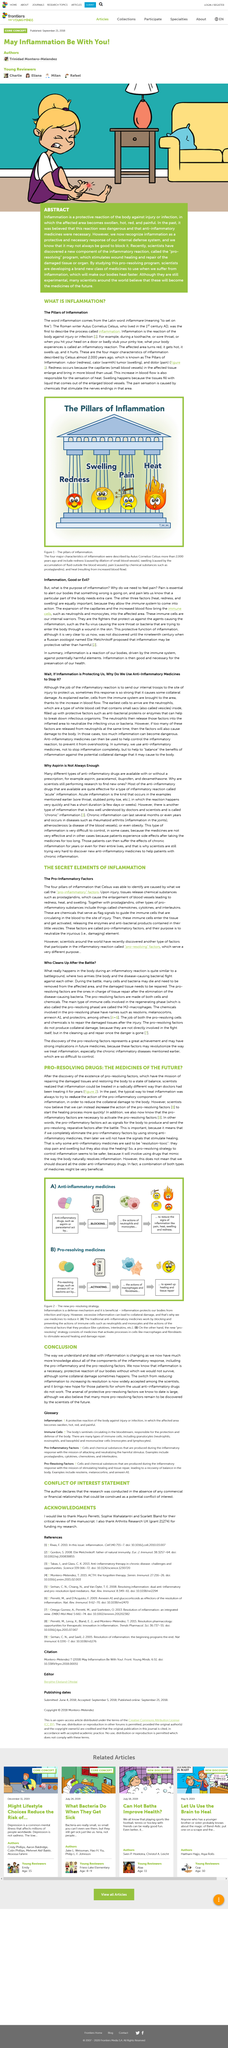Identify some key points in this picture. Anti-inflammatory drugs work by inhibiting the activities of neutrophils and monocytes. The use of anti-inflammatory medicine is intended to mitigate the inflammatory response. Pro-inflammatory factors serve as signals for the body to produce and send reparative factors in response to battle. Strong inflammation can lead to collateral damage. The Roman writer Aulus Cornelius Celsus lived in the 1st century AD. 